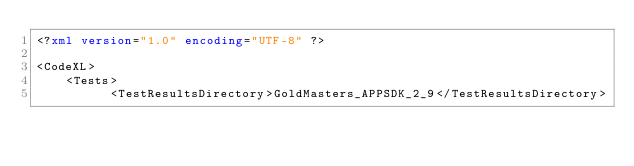<code> <loc_0><loc_0><loc_500><loc_500><_XML_><?xml version="1.0" encoding="UTF-8" ?>

<CodeXL>
    <Tests>
	        <TestResultsDirectory>GoldMasters_APPSDK_2_9</TestResultsDirectory></code> 